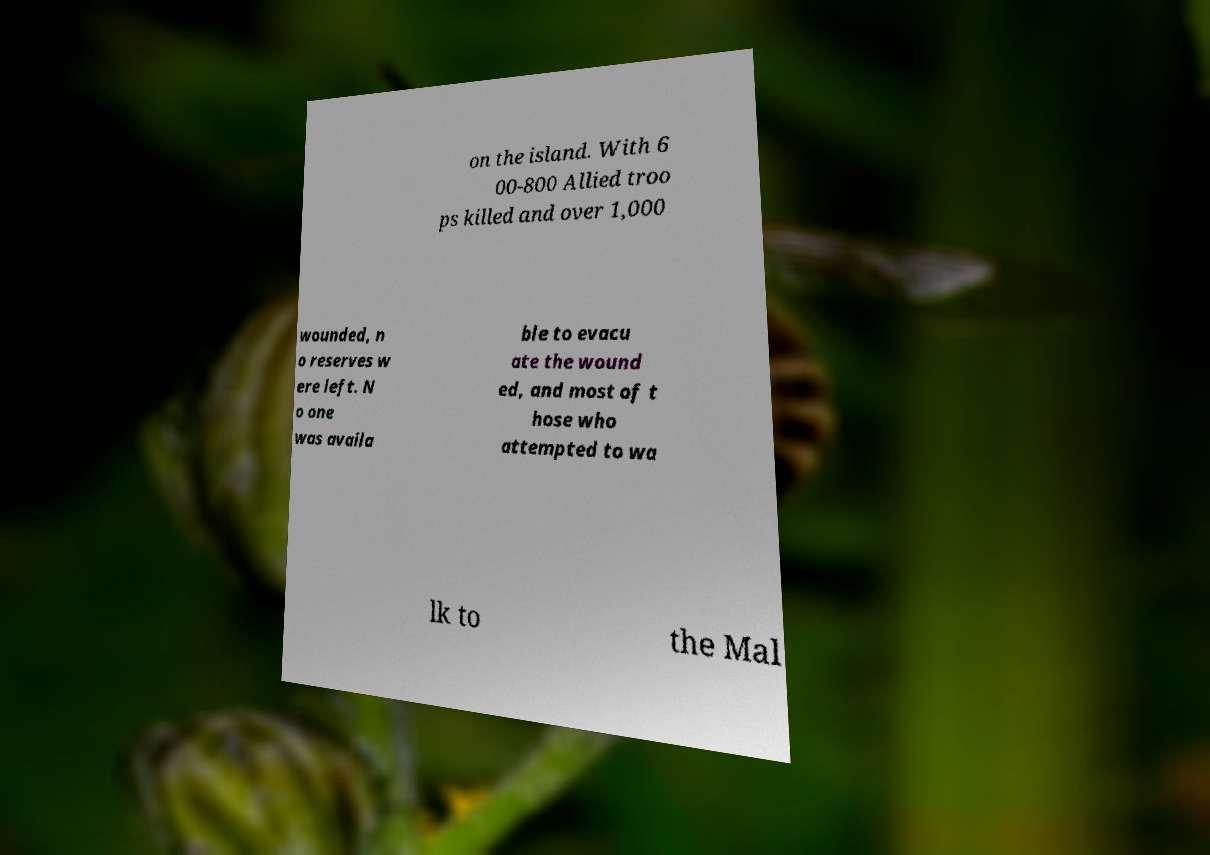I need the written content from this picture converted into text. Can you do that? on the island. With 6 00-800 Allied troo ps killed and over 1,000 wounded, n o reserves w ere left. N o one was availa ble to evacu ate the wound ed, and most of t hose who attempted to wa lk to the Mal 